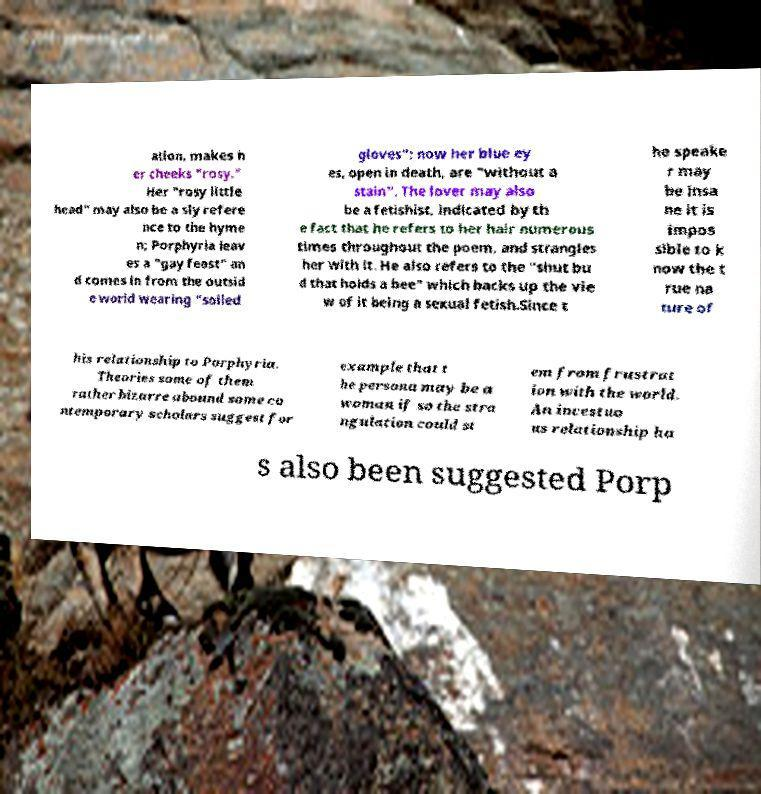Could you extract and type out the text from this image? ation, makes h er cheeks "rosy." Her "rosy little head" may also be a sly refere nce to the hyme n; Porphyria leav es a "gay feast" an d comes in from the outsid e world wearing "soiled gloves"; now her blue ey es, open in death, are "without a stain". The lover may also be a fetishist, indicated by th e fact that he refers to her hair numerous times throughout the poem, and strangles her with it. He also refers to the "shut bu d that holds a bee" which backs up the vie w of it being a sexual fetish.Since t he speake r may be insa ne it is impos sible to k now the t rue na ture of his relationship to Porphyria. Theories some of them rather bizarre abound some co ntemporary scholars suggest for example that t he persona may be a woman if so the stra ngulation could st em from frustrat ion with the world. An incestuo us relationship ha s also been suggested Porp 